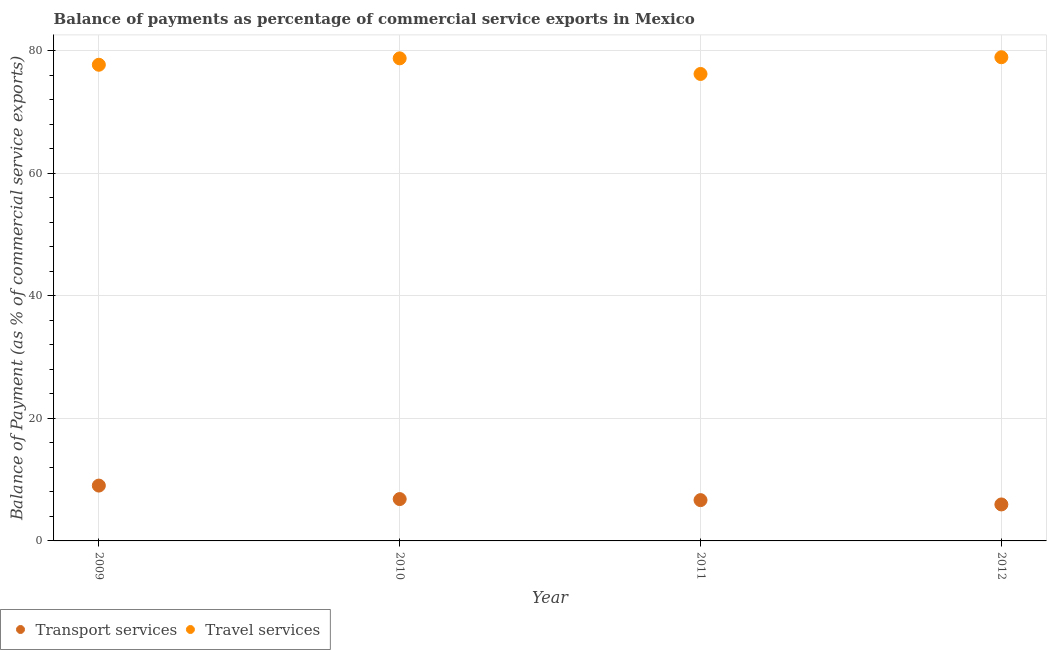How many different coloured dotlines are there?
Make the answer very short. 2. Is the number of dotlines equal to the number of legend labels?
Offer a terse response. Yes. What is the balance of payments of travel services in 2011?
Give a very brief answer. 76.17. Across all years, what is the maximum balance of payments of travel services?
Make the answer very short. 78.9. Across all years, what is the minimum balance of payments of travel services?
Offer a very short reply. 76.17. In which year was the balance of payments of transport services minimum?
Ensure brevity in your answer.  2012. What is the total balance of payments of travel services in the graph?
Provide a short and direct response. 311.48. What is the difference between the balance of payments of travel services in 2010 and that in 2011?
Your answer should be very brief. 2.55. What is the difference between the balance of payments of transport services in 2011 and the balance of payments of travel services in 2010?
Provide a short and direct response. -72.07. What is the average balance of payments of transport services per year?
Your answer should be very brief. 7.11. In the year 2009, what is the difference between the balance of payments of travel services and balance of payments of transport services?
Ensure brevity in your answer.  68.65. In how many years, is the balance of payments of travel services greater than 16 %?
Provide a succinct answer. 4. What is the ratio of the balance of payments of transport services in 2010 to that in 2012?
Keep it short and to the point. 1.15. What is the difference between the highest and the second highest balance of payments of transport services?
Your response must be concise. 2.2. What is the difference between the highest and the lowest balance of payments of transport services?
Keep it short and to the point. 3.08. In how many years, is the balance of payments of travel services greater than the average balance of payments of travel services taken over all years?
Your answer should be compact. 2. Is the sum of the balance of payments of transport services in 2011 and 2012 greater than the maximum balance of payments of travel services across all years?
Provide a short and direct response. No. Does the balance of payments of transport services monotonically increase over the years?
Provide a short and direct response. No. Is the balance of payments of transport services strictly less than the balance of payments of travel services over the years?
Provide a short and direct response. Yes. How many dotlines are there?
Provide a short and direct response. 2. Does the graph contain any zero values?
Provide a short and direct response. No. Where does the legend appear in the graph?
Your answer should be compact. Bottom left. How many legend labels are there?
Offer a terse response. 2. How are the legend labels stacked?
Provide a succinct answer. Horizontal. What is the title of the graph?
Ensure brevity in your answer.  Balance of payments as percentage of commercial service exports in Mexico. What is the label or title of the X-axis?
Your answer should be very brief. Year. What is the label or title of the Y-axis?
Give a very brief answer. Balance of Payment (as % of commercial service exports). What is the Balance of Payment (as % of commercial service exports) of Transport services in 2009?
Make the answer very short. 9.03. What is the Balance of Payment (as % of commercial service exports) of Travel services in 2009?
Offer a very short reply. 77.68. What is the Balance of Payment (as % of commercial service exports) in Transport services in 2010?
Ensure brevity in your answer.  6.83. What is the Balance of Payment (as % of commercial service exports) of Travel services in 2010?
Provide a succinct answer. 78.72. What is the Balance of Payment (as % of commercial service exports) in Transport services in 2011?
Make the answer very short. 6.65. What is the Balance of Payment (as % of commercial service exports) of Travel services in 2011?
Provide a succinct answer. 76.17. What is the Balance of Payment (as % of commercial service exports) of Transport services in 2012?
Offer a terse response. 5.95. What is the Balance of Payment (as % of commercial service exports) of Travel services in 2012?
Keep it short and to the point. 78.9. Across all years, what is the maximum Balance of Payment (as % of commercial service exports) of Transport services?
Provide a succinct answer. 9.03. Across all years, what is the maximum Balance of Payment (as % of commercial service exports) of Travel services?
Keep it short and to the point. 78.9. Across all years, what is the minimum Balance of Payment (as % of commercial service exports) in Transport services?
Your answer should be compact. 5.95. Across all years, what is the minimum Balance of Payment (as % of commercial service exports) in Travel services?
Provide a short and direct response. 76.17. What is the total Balance of Payment (as % of commercial service exports) in Transport services in the graph?
Provide a short and direct response. 28.46. What is the total Balance of Payment (as % of commercial service exports) of Travel services in the graph?
Provide a succinct answer. 311.48. What is the difference between the Balance of Payment (as % of commercial service exports) in Transport services in 2009 and that in 2010?
Make the answer very short. 2.2. What is the difference between the Balance of Payment (as % of commercial service exports) in Travel services in 2009 and that in 2010?
Ensure brevity in your answer.  -1.05. What is the difference between the Balance of Payment (as % of commercial service exports) in Transport services in 2009 and that in 2011?
Offer a very short reply. 2.37. What is the difference between the Balance of Payment (as % of commercial service exports) in Travel services in 2009 and that in 2011?
Give a very brief answer. 1.5. What is the difference between the Balance of Payment (as % of commercial service exports) in Transport services in 2009 and that in 2012?
Your answer should be compact. 3.08. What is the difference between the Balance of Payment (as % of commercial service exports) in Travel services in 2009 and that in 2012?
Ensure brevity in your answer.  -1.23. What is the difference between the Balance of Payment (as % of commercial service exports) in Transport services in 2010 and that in 2011?
Make the answer very short. 0.17. What is the difference between the Balance of Payment (as % of commercial service exports) of Travel services in 2010 and that in 2011?
Provide a short and direct response. 2.55. What is the difference between the Balance of Payment (as % of commercial service exports) of Transport services in 2010 and that in 2012?
Give a very brief answer. 0.87. What is the difference between the Balance of Payment (as % of commercial service exports) of Travel services in 2010 and that in 2012?
Offer a very short reply. -0.18. What is the difference between the Balance of Payment (as % of commercial service exports) in Transport services in 2011 and that in 2012?
Provide a succinct answer. 0.7. What is the difference between the Balance of Payment (as % of commercial service exports) of Travel services in 2011 and that in 2012?
Your answer should be very brief. -2.73. What is the difference between the Balance of Payment (as % of commercial service exports) in Transport services in 2009 and the Balance of Payment (as % of commercial service exports) in Travel services in 2010?
Provide a short and direct response. -69.7. What is the difference between the Balance of Payment (as % of commercial service exports) of Transport services in 2009 and the Balance of Payment (as % of commercial service exports) of Travel services in 2011?
Give a very brief answer. -67.15. What is the difference between the Balance of Payment (as % of commercial service exports) in Transport services in 2009 and the Balance of Payment (as % of commercial service exports) in Travel services in 2012?
Provide a short and direct response. -69.88. What is the difference between the Balance of Payment (as % of commercial service exports) in Transport services in 2010 and the Balance of Payment (as % of commercial service exports) in Travel services in 2011?
Your answer should be compact. -69.35. What is the difference between the Balance of Payment (as % of commercial service exports) of Transport services in 2010 and the Balance of Payment (as % of commercial service exports) of Travel services in 2012?
Ensure brevity in your answer.  -72.08. What is the difference between the Balance of Payment (as % of commercial service exports) in Transport services in 2011 and the Balance of Payment (as % of commercial service exports) in Travel services in 2012?
Your answer should be compact. -72.25. What is the average Balance of Payment (as % of commercial service exports) in Transport services per year?
Offer a terse response. 7.11. What is the average Balance of Payment (as % of commercial service exports) of Travel services per year?
Your answer should be very brief. 77.87. In the year 2009, what is the difference between the Balance of Payment (as % of commercial service exports) in Transport services and Balance of Payment (as % of commercial service exports) in Travel services?
Provide a short and direct response. -68.65. In the year 2010, what is the difference between the Balance of Payment (as % of commercial service exports) in Transport services and Balance of Payment (as % of commercial service exports) in Travel services?
Ensure brevity in your answer.  -71.9. In the year 2011, what is the difference between the Balance of Payment (as % of commercial service exports) of Transport services and Balance of Payment (as % of commercial service exports) of Travel services?
Provide a short and direct response. -69.52. In the year 2012, what is the difference between the Balance of Payment (as % of commercial service exports) of Transport services and Balance of Payment (as % of commercial service exports) of Travel services?
Offer a very short reply. -72.95. What is the ratio of the Balance of Payment (as % of commercial service exports) of Transport services in 2009 to that in 2010?
Provide a succinct answer. 1.32. What is the ratio of the Balance of Payment (as % of commercial service exports) in Travel services in 2009 to that in 2010?
Ensure brevity in your answer.  0.99. What is the ratio of the Balance of Payment (as % of commercial service exports) in Transport services in 2009 to that in 2011?
Offer a very short reply. 1.36. What is the ratio of the Balance of Payment (as % of commercial service exports) of Travel services in 2009 to that in 2011?
Your response must be concise. 1.02. What is the ratio of the Balance of Payment (as % of commercial service exports) in Transport services in 2009 to that in 2012?
Your answer should be compact. 1.52. What is the ratio of the Balance of Payment (as % of commercial service exports) of Travel services in 2009 to that in 2012?
Provide a succinct answer. 0.98. What is the ratio of the Balance of Payment (as % of commercial service exports) of Transport services in 2010 to that in 2011?
Give a very brief answer. 1.03. What is the ratio of the Balance of Payment (as % of commercial service exports) of Travel services in 2010 to that in 2011?
Provide a short and direct response. 1.03. What is the ratio of the Balance of Payment (as % of commercial service exports) of Transport services in 2010 to that in 2012?
Ensure brevity in your answer.  1.15. What is the ratio of the Balance of Payment (as % of commercial service exports) of Travel services in 2010 to that in 2012?
Give a very brief answer. 1. What is the ratio of the Balance of Payment (as % of commercial service exports) in Transport services in 2011 to that in 2012?
Your response must be concise. 1.12. What is the ratio of the Balance of Payment (as % of commercial service exports) of Travel services in 2011 to that in 2012?
Your answer should be compact. 0.97. What is the difference between the highest and the second highest Balance of Payment (as % of commercial service exports) in Transport services?
Your response must be concise. 2.2. What is the difference between the highest and the second highest Balance of Payment (as % of commercial service exports) in Travel services?
Provide a succinct answer. 0.18. What is the difference between the highest and the lowest Balance of Payment (as % of commercial service exports) of Transport services?
Provide a short and direct response. 3.08. What is the difference between the highest and the lowest Balance of Payment (as % of commercial service exports) in Travel services?
Provide a short and direct response. 2.73. 